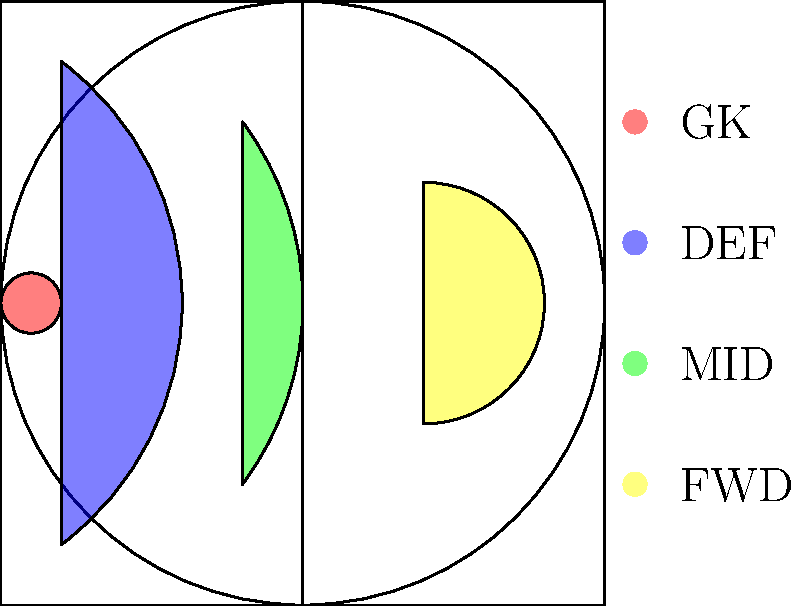Based on the heatmap image showing player movement patterns during a match, which position is represented by the yellow area? To determine the position represented by the yellow area, let's analyze the heatmap:

1. The image shows a football pitch with four distinct colored areas representing different player positions.

2. Each color corresponds to a specific position, as indicated by the legend:
   - Red: Goalkeeper (GK)
   - Blue: Defender (DEF)
   - Green: Midfielder (MID)
   - Yellow: Forward (FWD)

3. The yellow area is concentrated in the attacking third of the pitch, stretching from the center to the opponent's goal.

4. This area of the pitch is typically occupied by forwards, who are responsible for scoring goals and creating attacking opportunities.

5. The forward's movement pattern is characterized by:
   - Less involvement in the defensive half
   - High activity in and around the opponent's penalty area
   - Movement across the width of the attacking third

6. Comparing this to other positions:
   - The red area (goalkeeper) is confined to a small space near the team's goal
   - The blue area (defenders) is mostly in the defensive half
   - The green area (midfielders) covers the central part of the pitch

Therefore, based on the location and shape of the yellow area, it represents the forward position.
Answer: Forward 